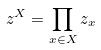Convert formula to latex. <formula><loc_0><loc_0><loc_500><loc_500>z ^ { X } = \prod _ { x \in X } z _ { x }</formula> 